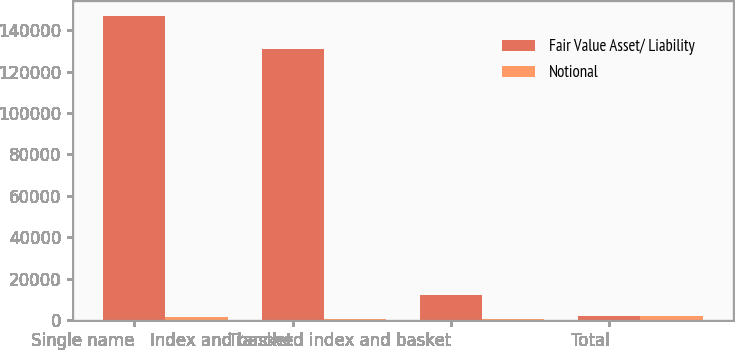<chart> <loc_0><loc_0><loc_500><loc_500><stacked_bar_chart><ecel><fcel>Single name<fcel>Index and basket<fcel>Tranched index and basket<fcel>Total<nl><fcel>Fair Value Asset/ Liability<fcel>146948<fcel>131073<fcel>11864<fcel>1960<nl><fcel>Notional<fcel>1277<fcel>341<fcel>342<fcel>1960<nl></chart> 